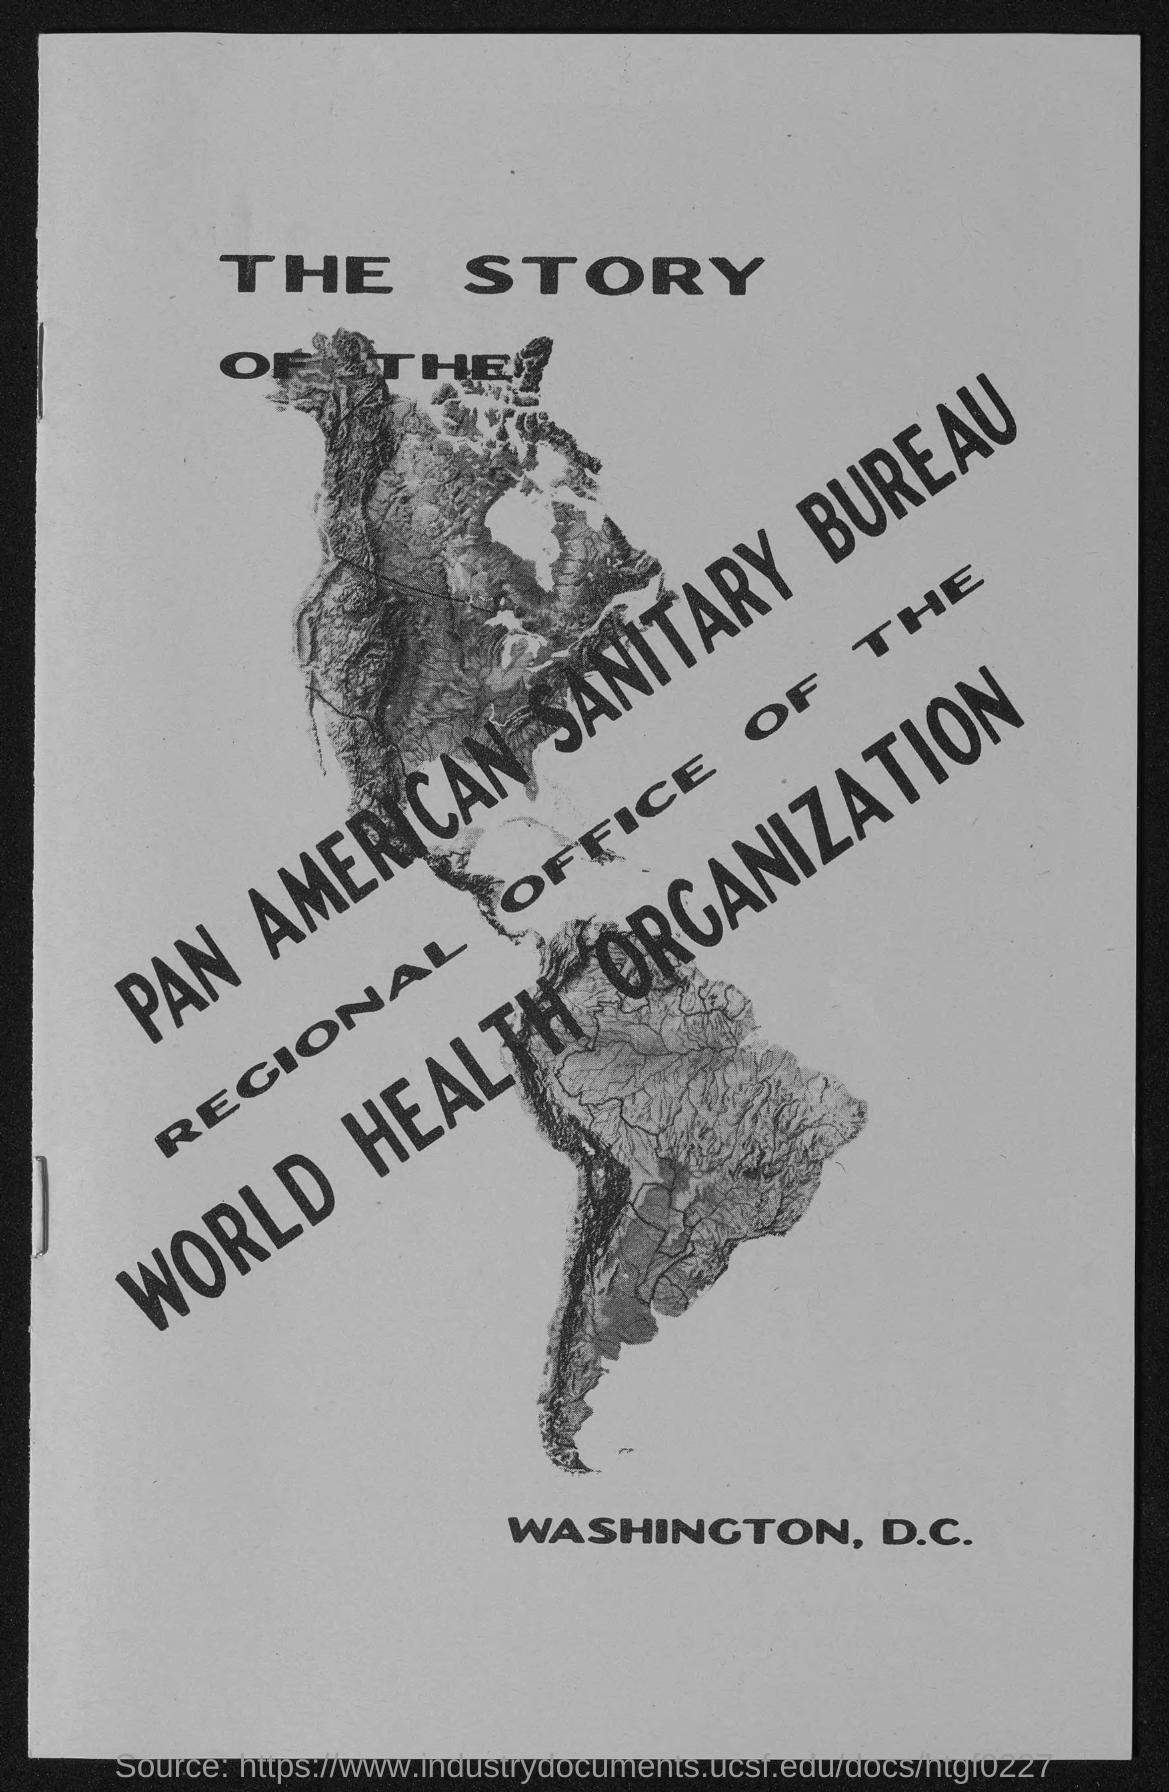Mention a couple of crucial points in this snapshot. Washington, D.C., is the place that is mentioned. The Pan American Sanitary Bureau is mentioned in the text. 